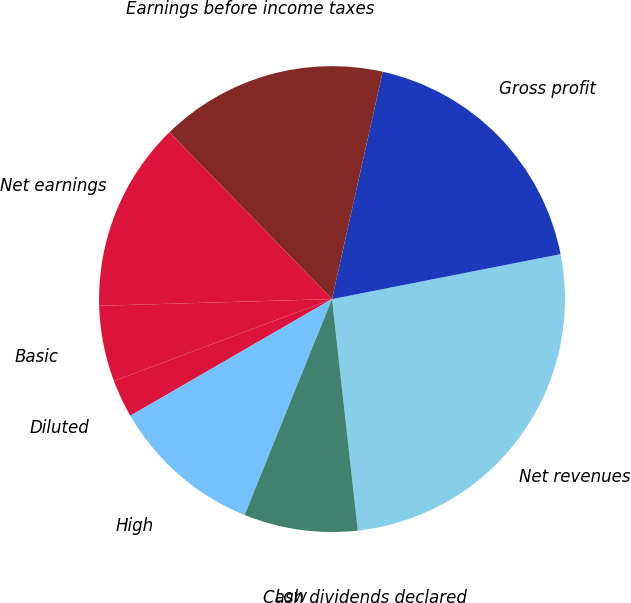<chart> <loc_0><loc_0><loc_500><loc_500><pie_chart><fcel>Net revenues<fcel>Gross profit<fcel>Earnings before income taxes<fcel>Net earnings<fcel>Basic<fcel>Diluted<fcel>High<fcel>Low<fcel>Cash dividends declared<nl><fcel>26.32%<fcel>18.42%<fcel>15.79%<fcel>13.16%<fcel>5.26%<fcel>2.63%<fcel>10.53%<fcel>7.89%<fcel>0.0%<nl></chart> 